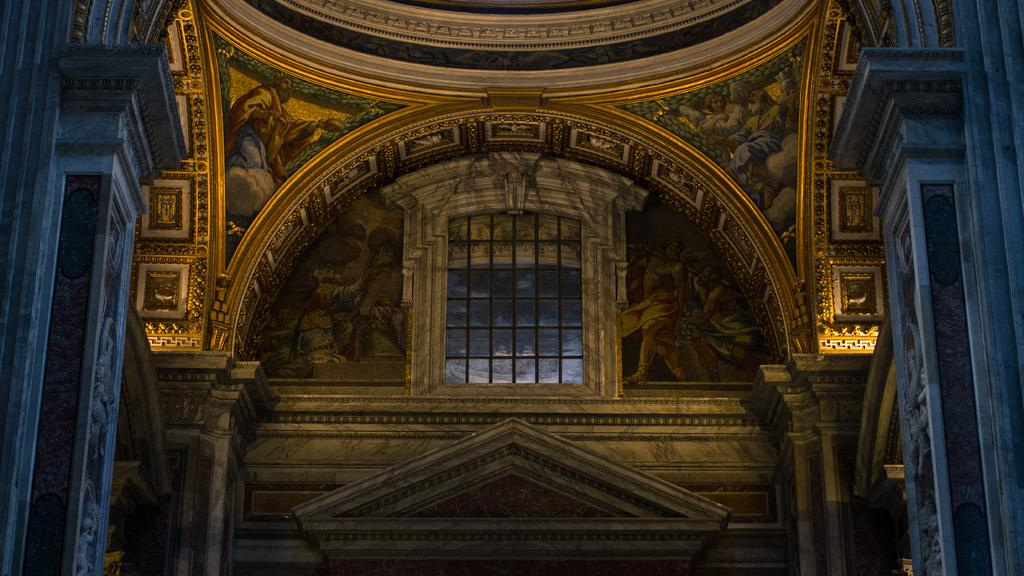Where was the image taken? The image was taken inside a room. What can be seen on the walls in the room? There are paintings on the wall. Is there any natural light source in the room? Yes, there is a window in the wall. What type of rock is being used as a sack in the image? There is no rock or sack present in the image. How is the division of space being utilized in the image? The image does not show any specific division of space; it only depicts a room with paintings on the wall and a window. 